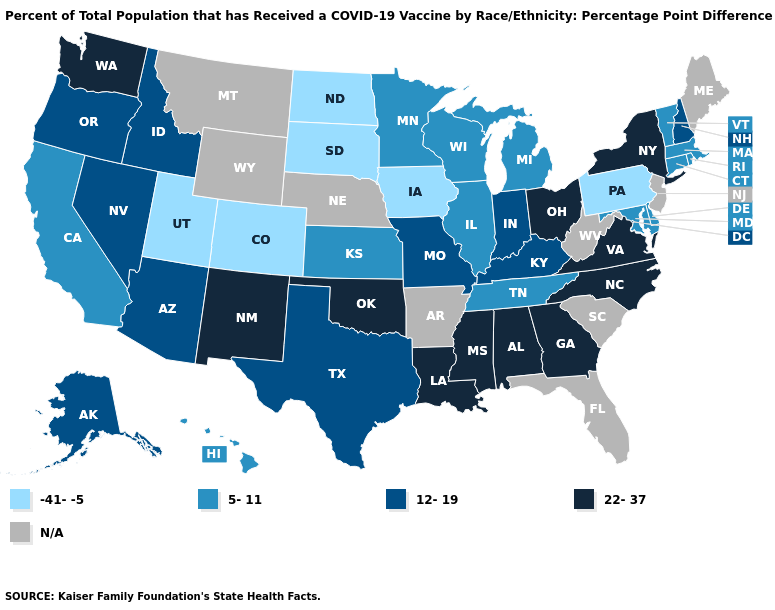Among the states that border New Mexico , which have the lowest value?
Be succinct. Colorado, Utah. What is the value of Maine?
Write a very short answer. N/A. Does New York have the highest value in the Northeast?
Short answer required. Yes. What is the value of Georgia?
Keep it brief. 22-37. What is the highest value in states that border Indiana?
Quick response, please. 22-37. Which states hav the highest value in the Northeast?
Short answer required. New York. Does Virginia have the highest value in the USA?
Concise answer only. Yes. Among the states that border North Carolina , which have the highest value?
Answer briefly. Georgia, Virginia. What is the value of Nevada?
Quick response, please. 12-19. What is the value of New Jersey?
Write a very short answer. N/A. What is the lowest value in the Northeast?
Keep it brief. -41--5. Name the states that have a value in the range 12-19?
Give a very brief answer. Alaska, Arizona, Idaho, Indiana, Kentucky, Missouri, Nevada, New Hampshire, Oregon, Texas. Does Delaware have the highest value in the USA?
Answer briefly. No. 